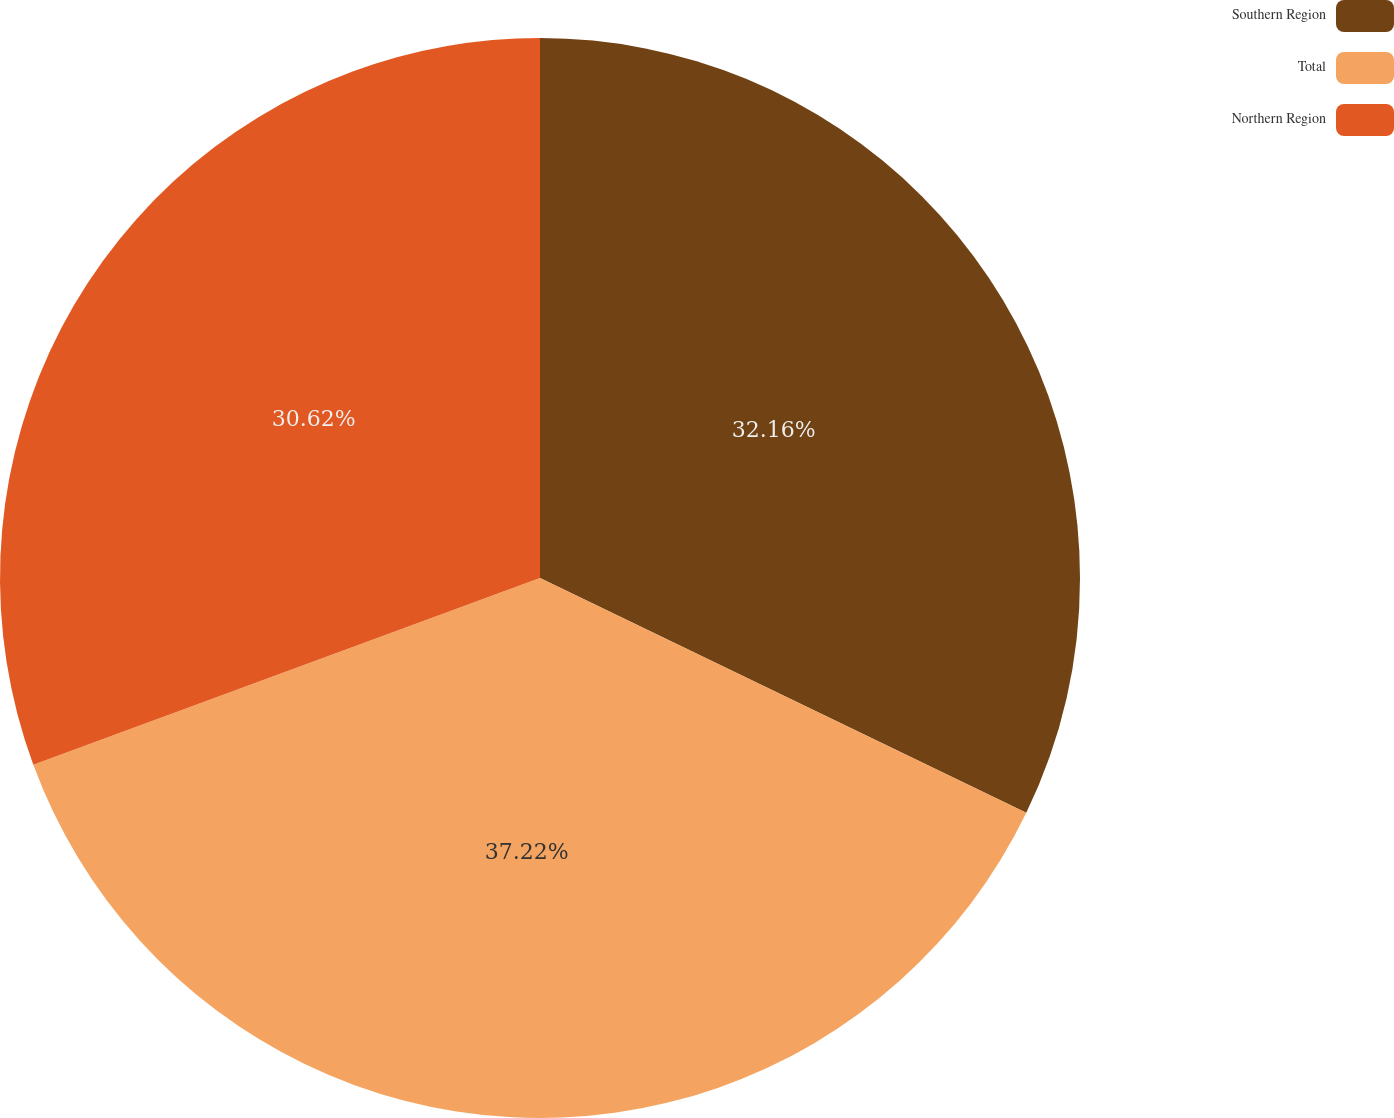<chart> <loc_0><loc_0><loc_500><loc_500><pie_chart><fcel>Southern Region<fcel>Total<fcel>Northern Region<nl><fcel>32.16%<fcel>37.22%<fcel>30.62%<nl></chart> 